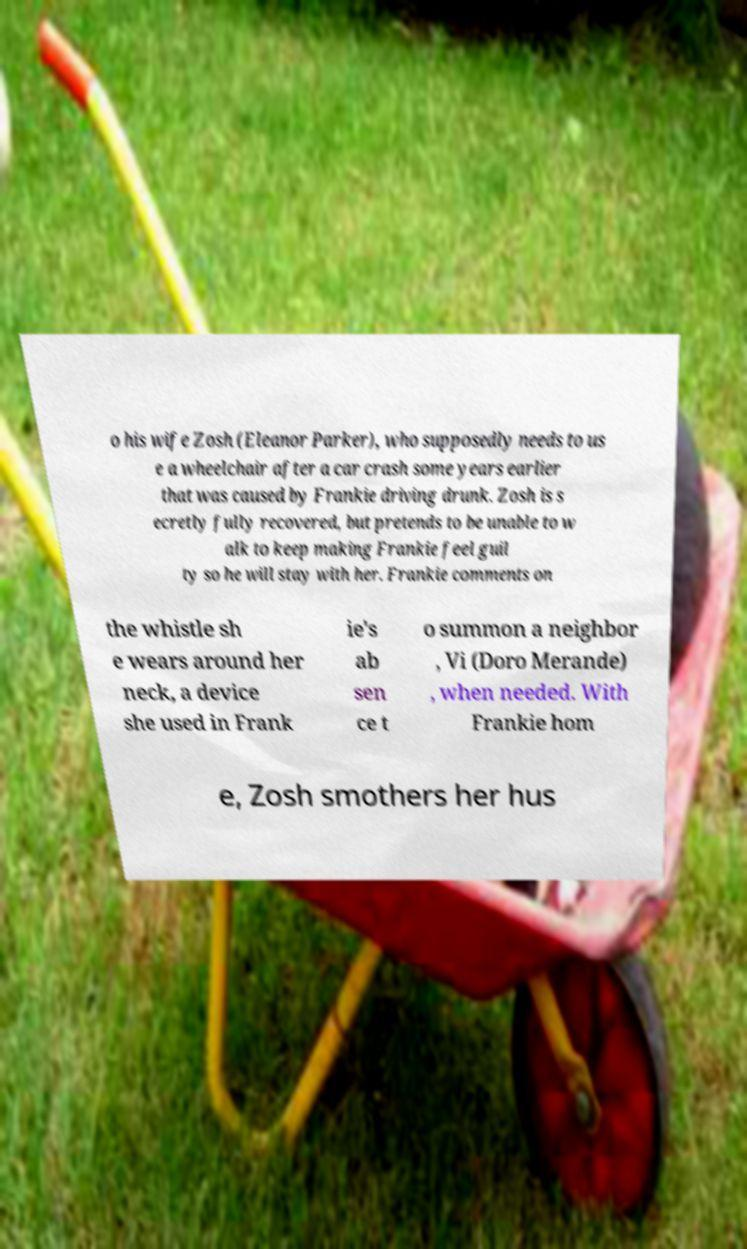Could you extract and type out the text from this image? o his wife Zosh (Eleanor Parker), who supposedly needs to us e a wheelchair after a car crash some years earlier that was caused by Frankie driving drunk. Zosh is s ecretly fully recovered, but pretends to be unable to w alk to keep making Frankie feel guil ty so he will stay with her. Frankie comments on the whistle sh e wears around her neck, a device she used in Frank ie's ab sen ce t o summon a neighbor , Vi (Doro Merande) , when needed. With Frankie hom e, Zosh smothers her hus 